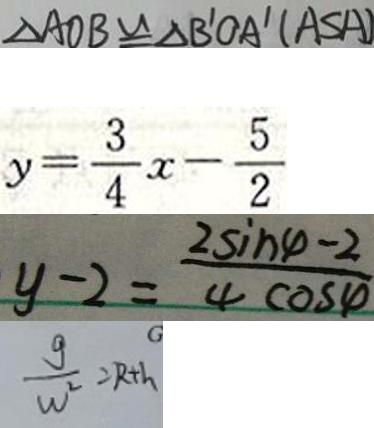<formula> <loc_0><loc_0><loc_500><loc_500>\Delta A O B \cong \Delta B ^ { \prime } O A ^ { \prime } ( A S A ) 
 y = \frac { 3 } { 4 } x - \frac { 5 } { 2 } 
 y - 2 = \frac { 2 \sin \varphi - 2 } { 4 \cos \varphi } 
 \frac { g } { w ^ { 2 } } = R + h</formula> 